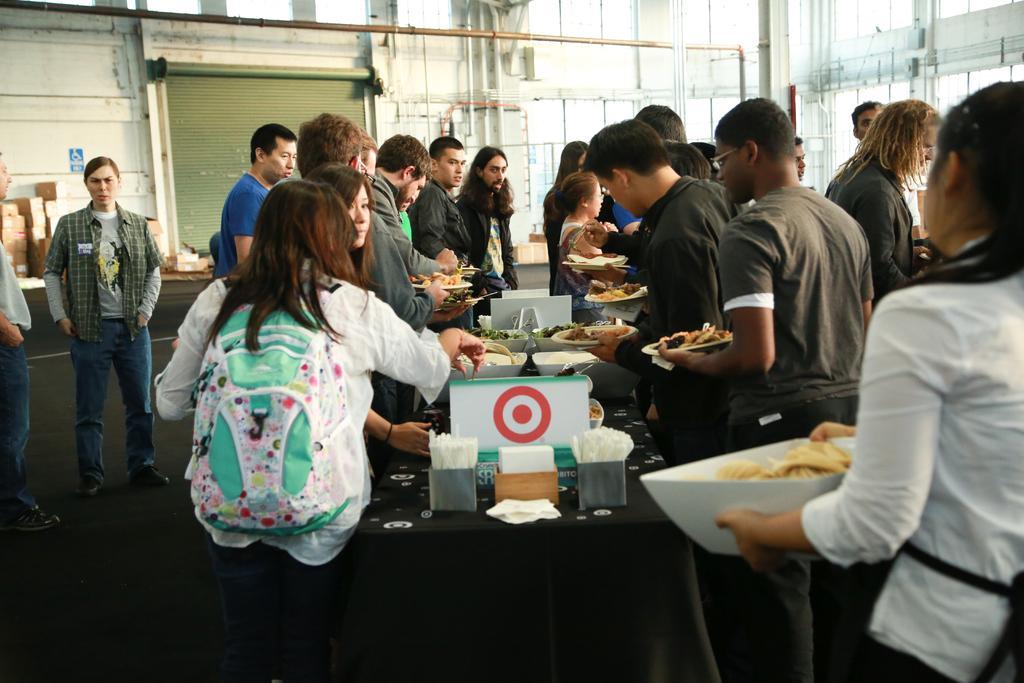Please provide a concise description of this image. In this picture, There are some people standing and there are some food items on the table of black color, In the background there is a white color wall and there is a shutter in green color. 